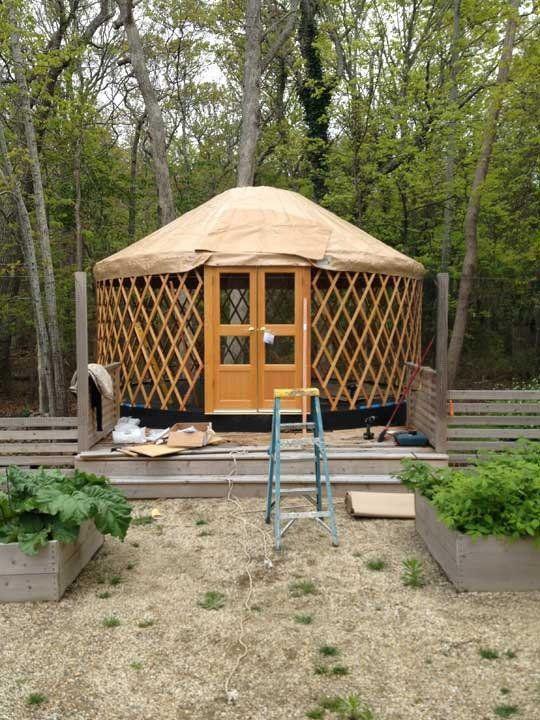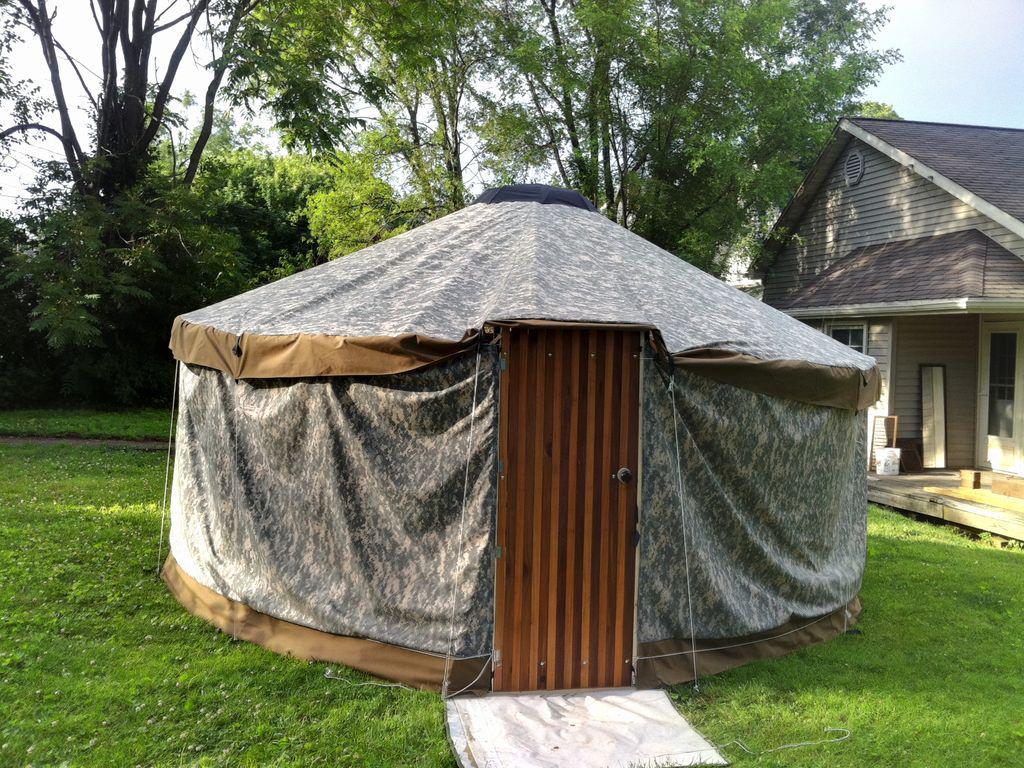The first image is the image on the left, the second image is the image on the right. Examine the images to the left and right. Is the description "Two round houses are dark teal green with light colored conical roofs." accurate? Answer yes or no. No. The first image is the image on the left, the second image is the image on the right. Given the left and right images, does the statement "At least one image shows a circular home with green exterior 'walls'." hold true? Answer yes or no. No. 